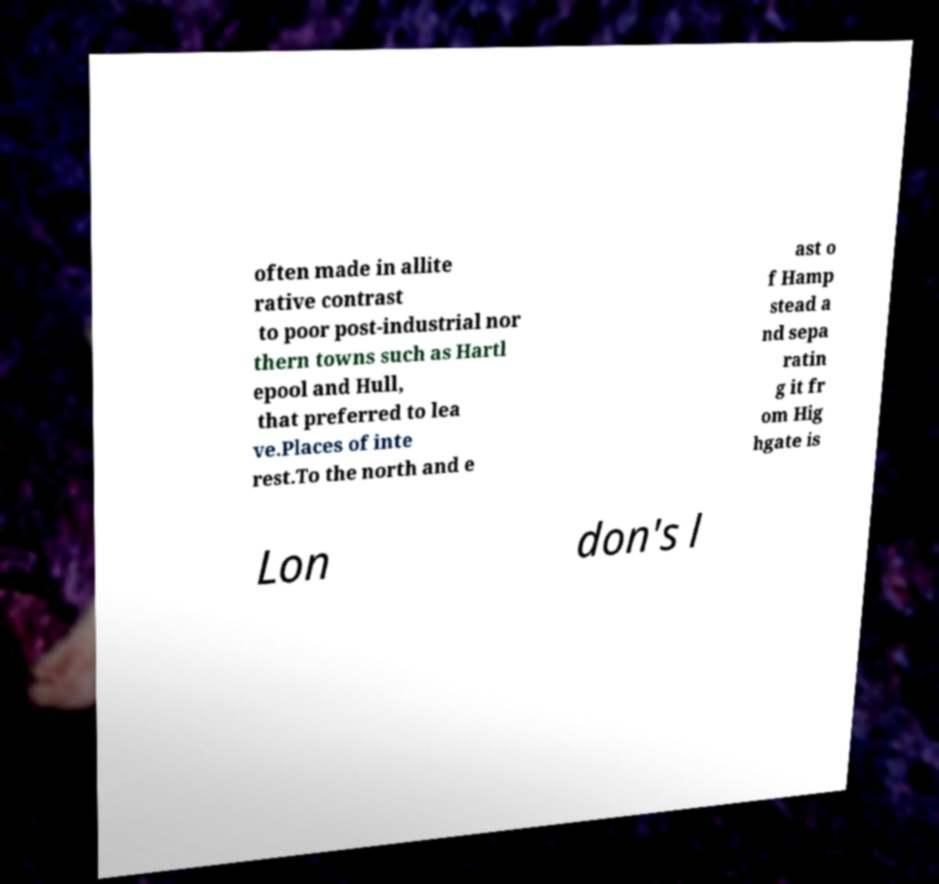Could you assist in decoding the text presented in this image and type it out clearly? often made in allite rative contrast to poor post-industrial nor thern towns such as Hartl epool and Hull, that preferred to lea ve.Places of inte rest.To the north and e ast o f Hamp stead a nd sepa ratin g it fr om Hig hgate is Lon don's l 